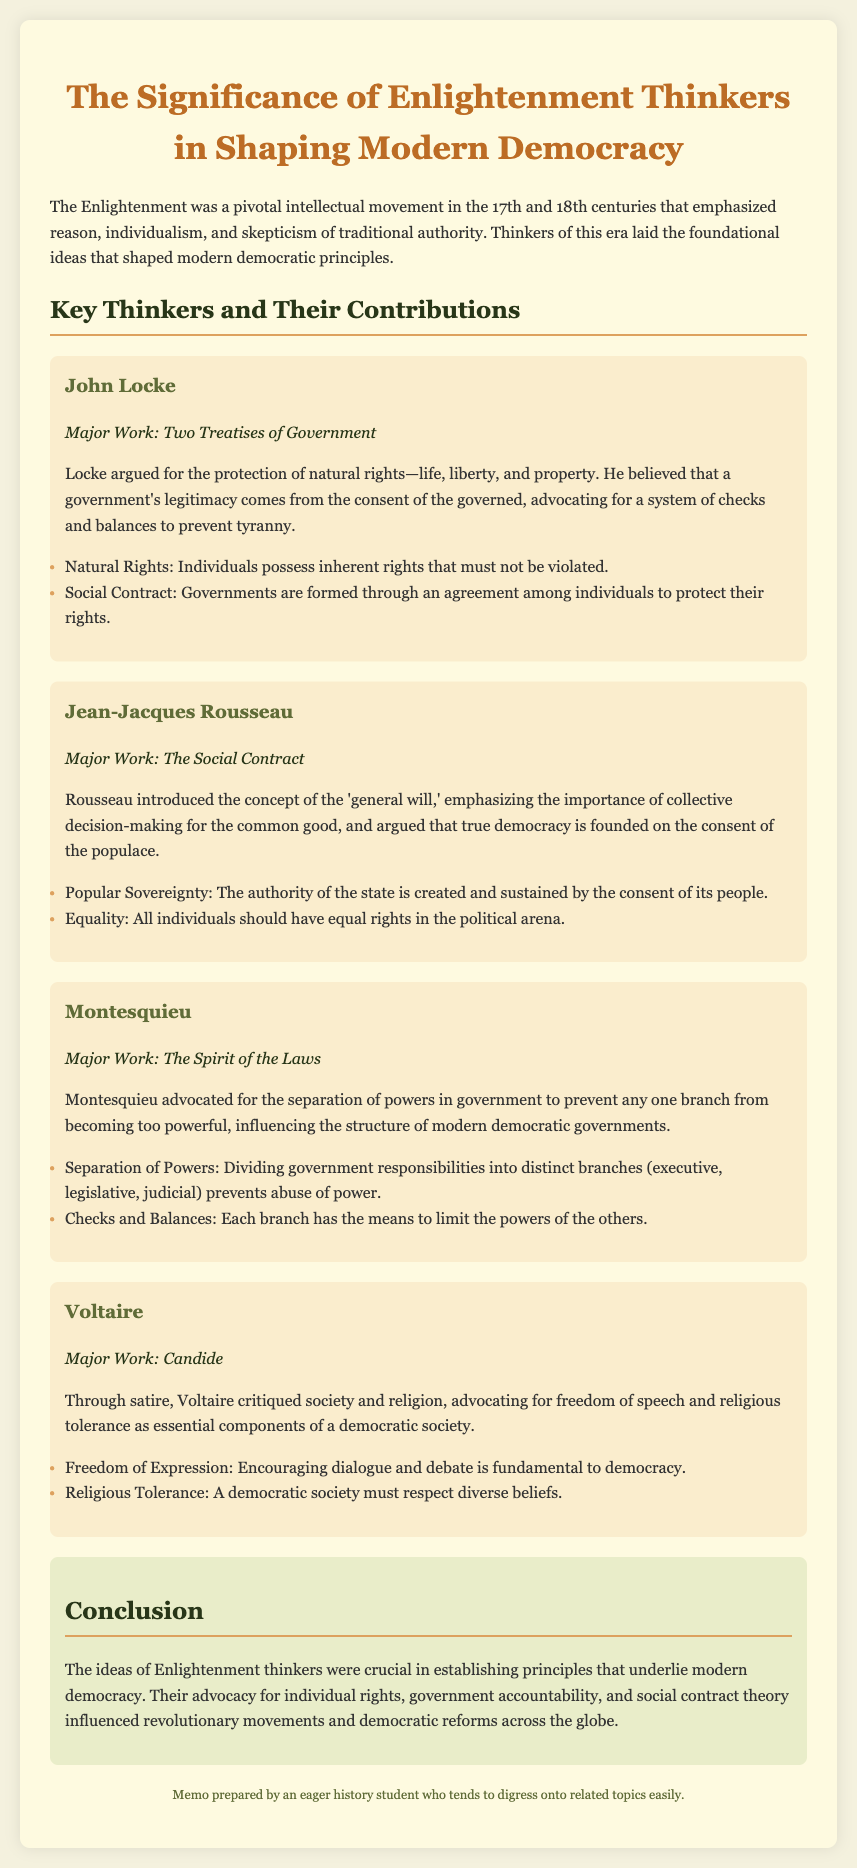What is the major work of John Locke? John Locke’s major work is highlighted in the document as the foundation of his ideas on government and rights.
Answer: Two Treatises of Government What concept did Rousseau introduce? The document specifically mentions Rousseau introduced the concept of the 'general will.'
Answer: General will Which thinker advocated for the separation of powers? The document indicates that Montesquieu significantly influenced this principle.
Answer: Montesquieu What is the significance of natural rights according to Locke? Locke emphasized the importance of protecting these rights as fundamental in his philosophy.
Answer: Life, liberty, and property What does Voltaire advocate for as essential components of a democratic society? The document outlines Voltaire’s key advocacies that are foundational to democratic ideals.
Answer: Freedom of speech and religious tolerance How many major thinkers are discussed in the memo? The content presents the contributions of multiple thinkers, listed sequentially in the document.
Answer: Four What is the primary theme of the Enlightenment as per the memo? The document summarizes the overarching themes that define this intellectual movement.
Answer: Reason, individualism, and skepticism of traditional authority What did Montesquieu believe would prevent the abuse of power? Montesquieu's idea is elucidated in the document and relates directly to governmental structure.
Answer: Separation of powers What was a major influence of Enlightenment thinkers on global movements? The conclusion notes a significant impact of their ideas over time.
Answer: Revolutionary movements and democratic reforms 